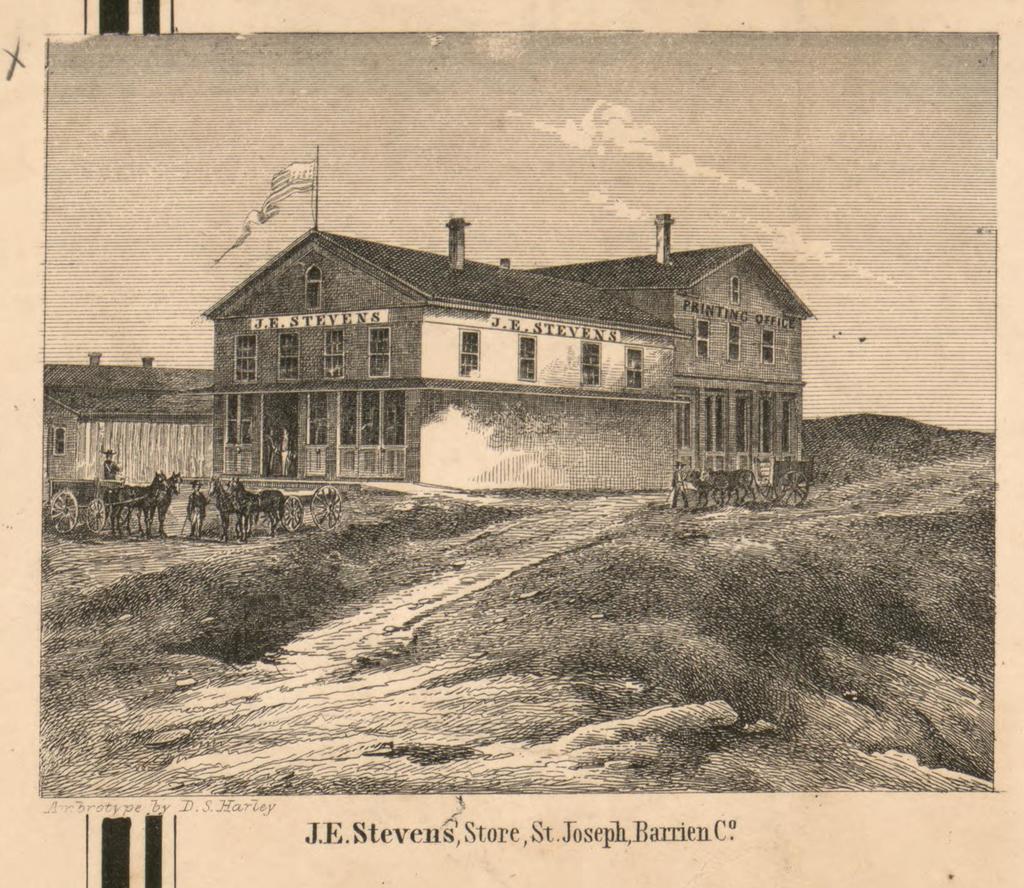How would you summarize this image in a sentence or two? This is black and white image where we can see building. On top of the building flag is there. Bottom of the image horses and carts are there and grassy land is present. Bottom of the image some text is written. 